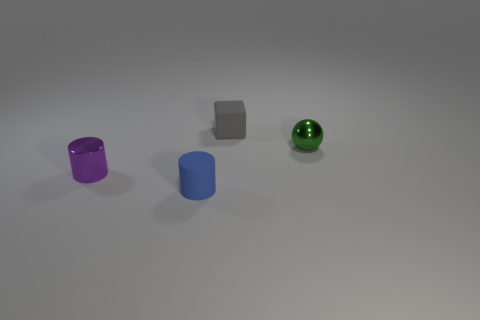What number of purple objects are either tiny matte objects or shiny cylinders?
Ensure brevity in your answer.  1. What size is the blue object that is the same material as the small cube?
Give a very brief answer. Small. How many other tiny things have the same shape as the tiny purple object?
Make the answer very short. 1. Are there more matte objects behind the metal cylinder than small purple metallic things in front of the rubber cylinder?
Your answer should be very brief. Yes. There is a purple cylinder that is the same size as the green shiny object; what is it made of?
Your answer should be compact. Metal. How many things are either small purple balls or small rubber things in front of the small metallic cylinder?
Provide a succinct answer. 1. Is the size of the green metallic sphere the same as the matte object that is on the left side of the small gray thing?
Provide a short and direct response. Yes. What number of blocks are blue matte objects or rubber objects?
Your answer should be compact. 1. How many objects are behind the small blue cylinder and in front of the green sphere?
Offer a very short reply. 1. There is a tiny thing that is right of the gray matte cube; what shape is it?
Ensure brevity in your answer.  Sphere. 